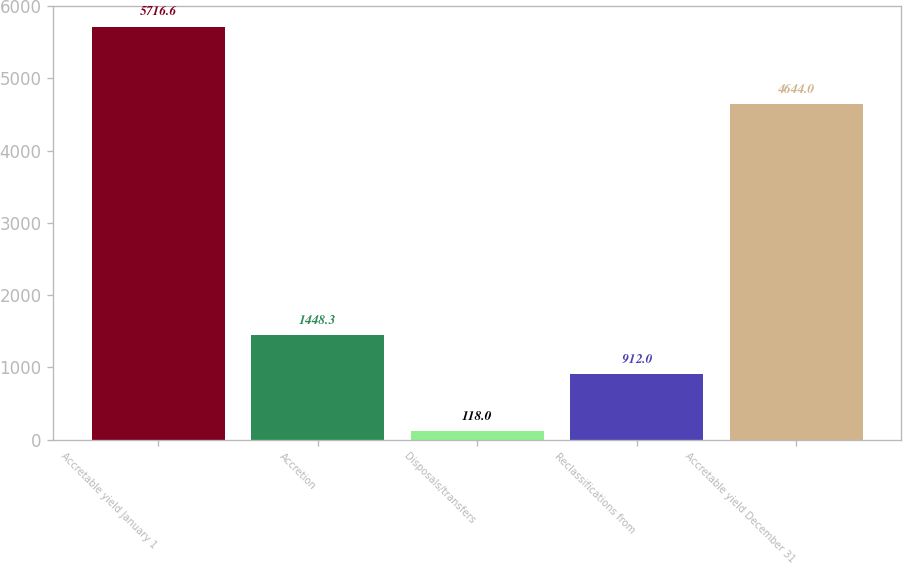Convert chart to OTSL. <chart><loc_0><loc_0><loc_500><loc_500><bar_chart><fcel>Accretable yield January 1<fcel>Accretion<fcel>Disposals/transfers<fcel>Reclassifications from<fcel>Accretable yield December 31<nl><fcel>5716.6<fcel>1448.3<fcel>118<fcel>912<fcel>4644<nl></chart> 